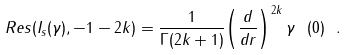<formula> <loc_0><loc_0><loc_500><loc_500>R e s ( I _ { s } ( \gamma ) , - 1 - 2 k ) = \frac { 1 } { \Gamma ( 2 k + 1 ) } { \left ( \frac { d } { d r } \right ) } ^ { 2 k } \, \gamma \ ( 0 ) \ .</formula> 